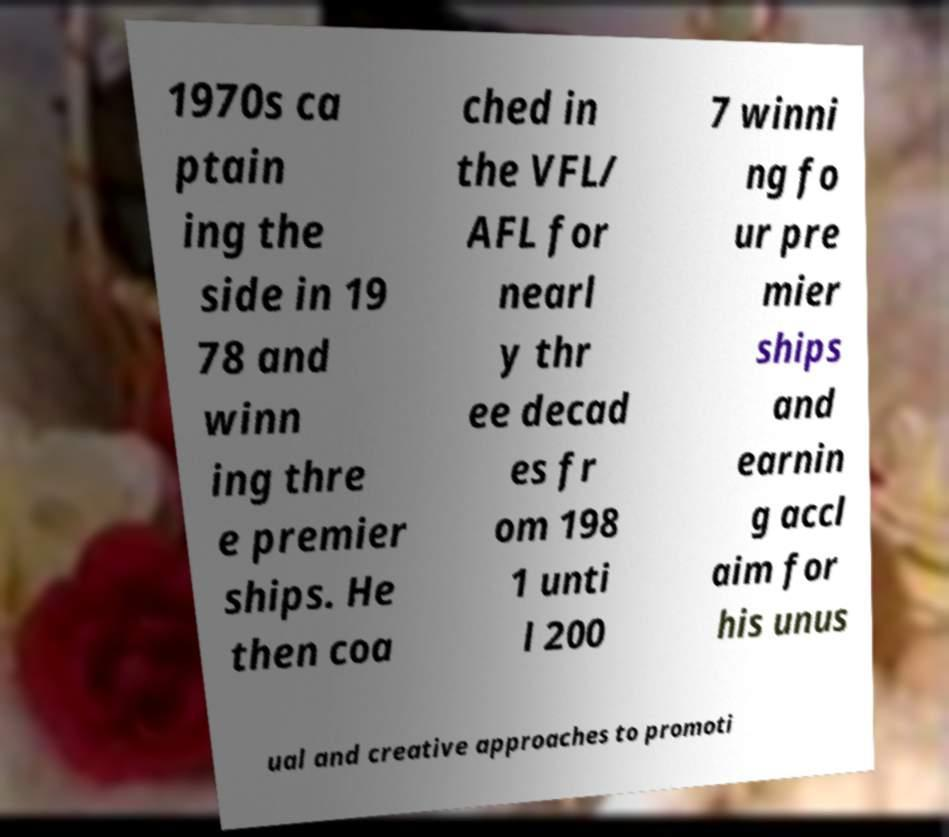Could you extract and type out the text from this image? 1970s ca ptain ing the side in 19 78 and winn ing thre e premier ships. He then coa ched in the VFL/ AFL for nearl y thr ee decad es fr om 198 1 unti l 200 7 winni ng fo ur pre mier ships and earnin g accl aim for his unus ual and creative approaches to promoti 